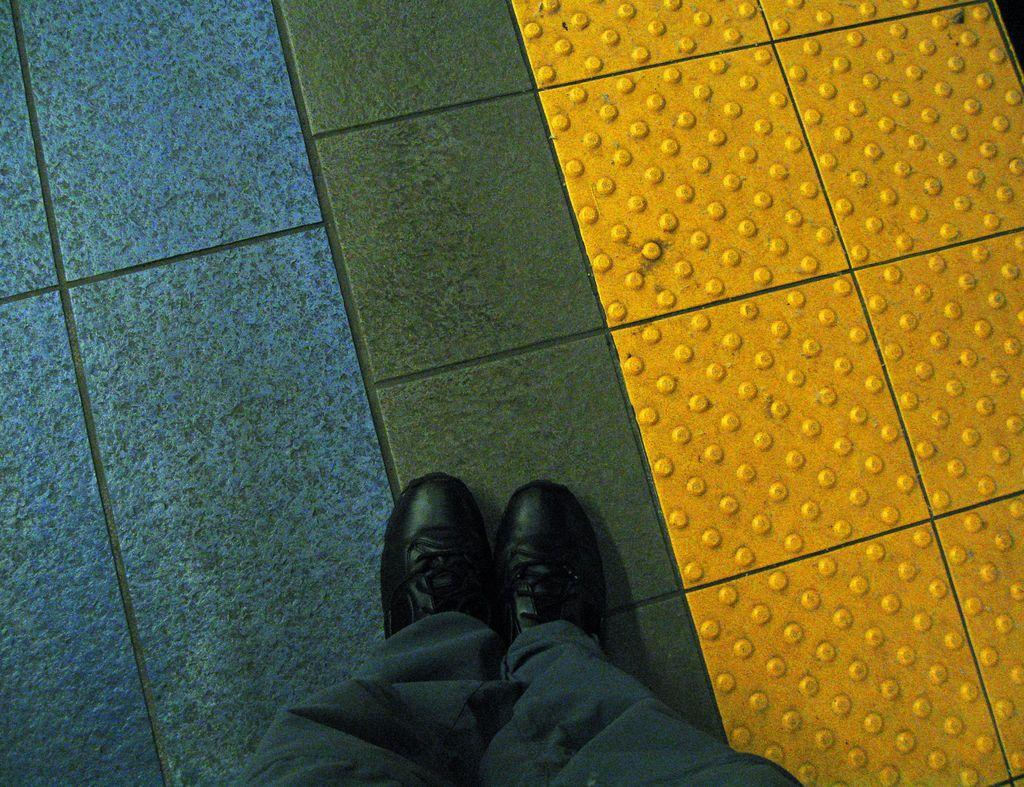Who or what is the main subject in the image? There is a person in the image. What part of the person's body can be seen at the bottom of the image? The person's legs are visible at the bottom of the image. What type of clothing is the person wearing on their legs? The person is wearing pants. What type of footwear is the person wearing? The person is wearing shoes. What type of surface is visible in the background of the image? There is a floor visible in the background of the image. What type of sack is the person carrying in the image? There is no sack present in the image. How does the sand appear in the image? There is no sand present in the image. 